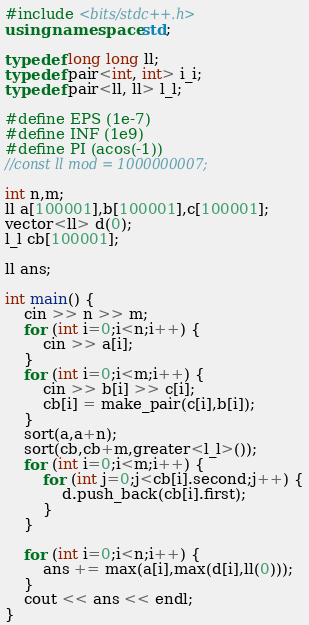<code> <loc_0><loc_0><loc_500><loc_500><_C++_>#include <bits/stdc++.h>
using namespace std;

typedef long long ll;
typedef pair<int, int> i_i;
typedef pair<ll, ll> l_l;
 
#define EPS (1e-7)
#define INF (1e9)
#define PI (acos(-1))
//const ll mod = 1000000007;

int n,m;
ll a[100001],b[100001],c[100001];
vector<ll> d(0);
l_l cb[100001];

ll ans;

int main() {
    cin >> n >> m;
    for (int i=0;i<n;i++) {
        cin >> a[i];
    }
    for (int i=0;i<m;i++) {
        cin >> b[i] >> c[i];
        cb[i] = make_pair(c[i],b[i]);
    }
    sort(a,a+n);
    sort(cb,cb+m,greater<l_l>());
    for (int i=0;i<m;i++) {
        for (int j=0;j<cb[i].second;j++) {
            d.push_back(cb[i].first);
        }
    }

    for (int i=0;i<n;i++) {
        ans += max(a[i],max(d[i],ll(0)));
    }
    cout << ans << endl;
}
</code> 